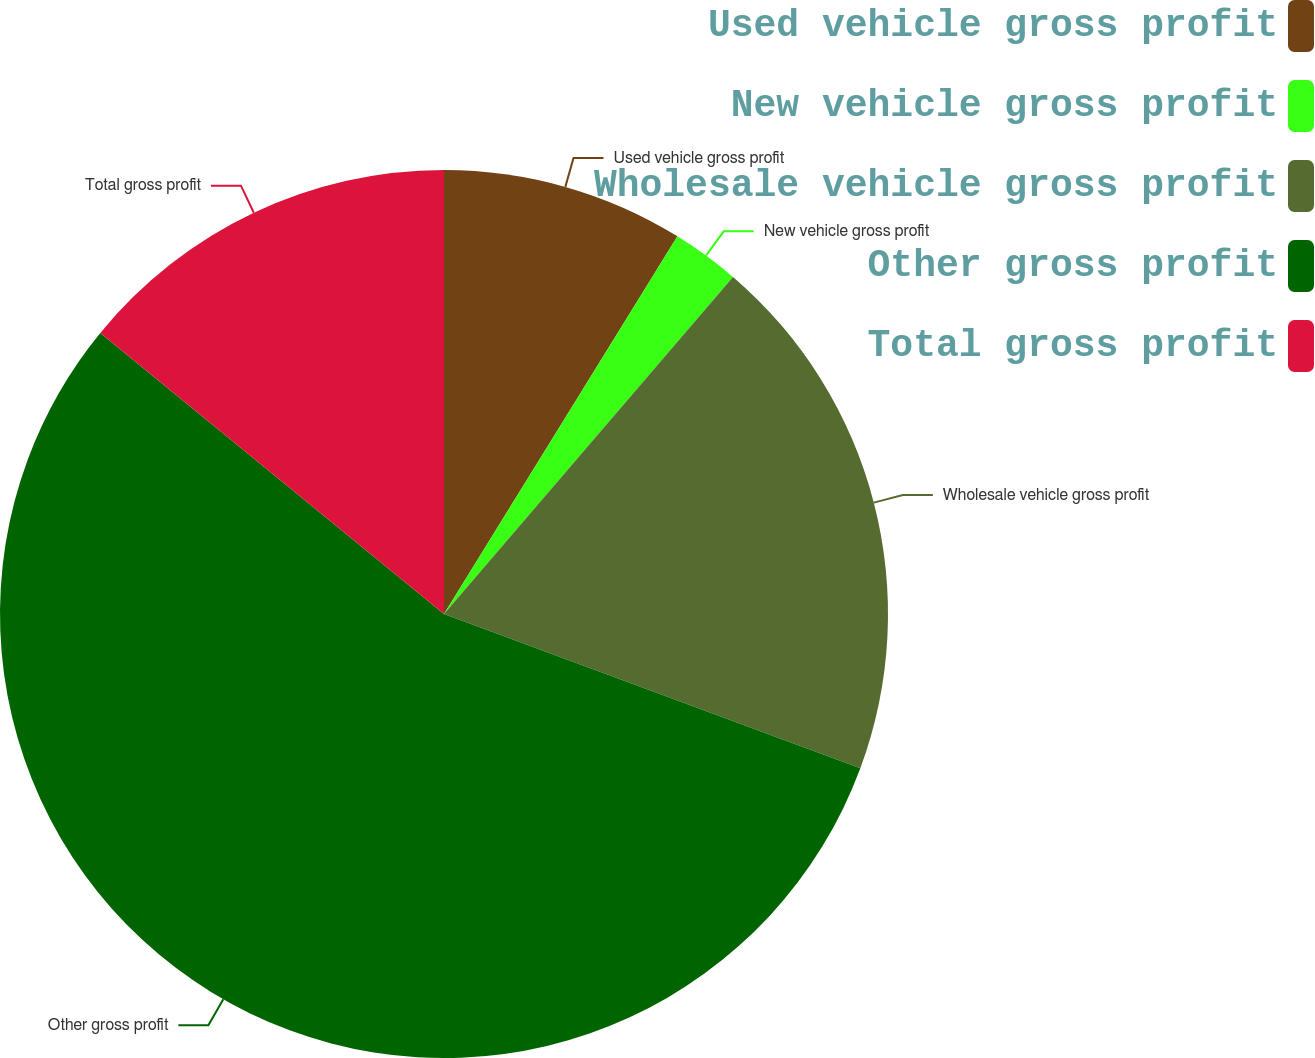Convert chart to OTSL. <chart><loc_0><loc_0><loc_500><loc_500><pie_chart><fcel>Used vehicle gross profit<fcel>New vehicle gross profit<fcel>Wholesale vehicle gross profit<fcel>Other gross profit<fcel>Total gross profit<nl><fcel>8.81%<fcel>2.47%<fcel>19.37%<fcel>55.26%<fcel>14.09%<nl></chart> 